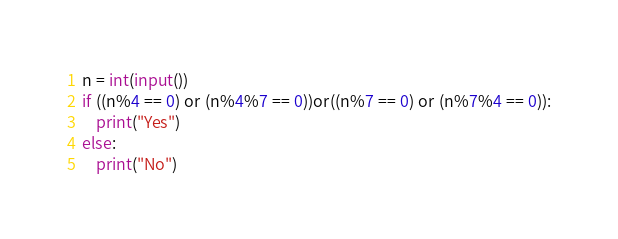Convert code to text. <code><loc_0><loc_0><loc_500><loc_500><_Python_>n = int(input())
if ((n%4 == 0) or (n%4%7 == 0))or((n%7 == 0) or (n%7%4 == 0)):
    print("Yes")
else:
    print("No")
</code> 